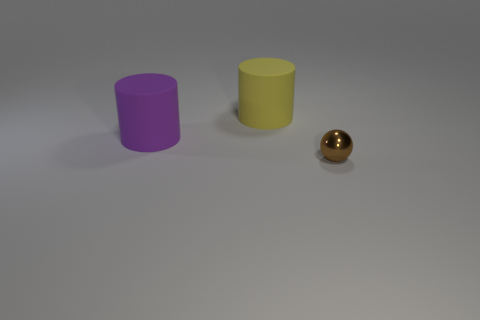Add 1 metallic objects. How many objects exist? 4 Subtract all cylinders. How many objects are left? 1 Subtract 0 blue cylinders. How many objects are left? 3 Subtract all purple metallic spheres. Subtract all purple matte objects. How many objects are left? 2 Add 1 small balls. How many small balls are left? 2 Add 1 purple cylinders. How many purple cylinders exist? 2 